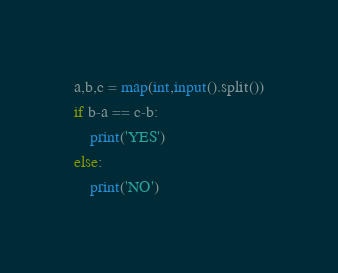Convert code to text. <code><loc_0><loc_0><loc_500><loc_500><_Python_>a,b,c = map(int,input().split())
if b-a == c-b:
    print('YES')
else:
    print('NO')
</code> 